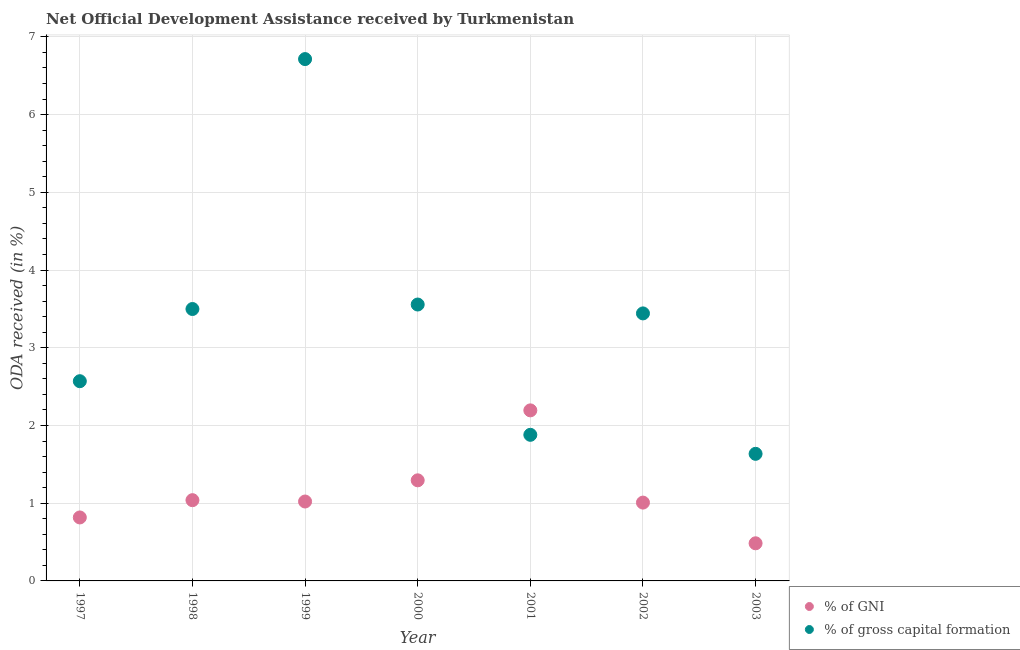How many different coloured dotlines are there?
Ensure brevity in your answer.  2. Is the number of dotlines equal to the number of legend labels?
Provide a succinct answer. Yes. What is the oda received as percentage of gni in 1999?
Your answer should be very brief. 1.02. Across all years, what is the maximum oda received as percentage of gni?
Give a very brief answer. 2.19. Across all years, what is the minimum oda received as percentage of gni?
Your response must be concise. 0.48. What is the total oda received as percentage of gross capital formation in the graph?
Offer a terse response. 23.29. What is the difference between the oda received as percentage of gross capital formation in 1997 and that in 1998?
Your response must be concise. -0.93. What is the difference between the oda received as percentage of gross capital formation in 2003 and the oda received as percentage of gni in 2000?
Provide a succinct answer. 0.34. What is the average oda received as percentage of gni per year?
Offer a terse response. 1.12. In the year 1997, what is the difference between the oda received as percentage of gni and oda received as percentage of gross capital formation?
Your answer should be very brief. -1.75. What is the ratio of the oda received as percentage of gni in 1997 to that in 2003?
Your response must be concise. 1.69. Is the difference between the oda received as percentage of gross capital formation in 1997 and 1999 greater than the difference between the oda received as percentage of gni in 1997 and 1999?
Ensure brevity in your answer.  No. What is the difference between the highest and the second highest oda received as percentage of gni?
Give a very brief answer. 0.9. What is the difference between the highest and the lowest oda received as percentage of gross capital formation?
Provide a short and direct response. 5.08. In how many years, is the oda received as percentage of gni greater than the average oda received as percentage of gni taken over all years?
Ensure brevity in your answer.  2. Is the oda received as percentage of gross capital formation strictly greater than the oda received as percentage of gni over the years?
Your answer should be compact. No. How many dotlines are there?
Offer a very short reply. 2. How many years are there in the graph?
Provide a succinct answer. 7. What is the difference between two consecutive major ticks on the Y-axis?
Your answer should be very brief. 1. Where does the legend appear in the graph?
Provide a short and direct response. Bottom right. How many legend labels are there?
Ensure brevity in your answer.  2. What is the title of the graph?
Your answer should be very brief. Net Official Development Assistance received by Turkmenistan. Does "Primary" appear as one of the legend labels in the graph?
Keep it short and to the point. No. What is the label or title of the X-axis?
Provide a succinct answer. Year. What is the label or title of the Y-axis?
Your answer should be very brief. ODA received (in %). What is the ODA received (in %) of % of GNI in 1997?
Your answer should be compact. 0.82. What is the ODA received (in %) of % of gross capital formation in 1997?
Your response must be concise. 2.57. What is the ODA received (in %) of % of GNI in 1998?
Your answer should be compact. 1.04. What is the ODA received (in %) in % of gross capital formation in 1998?
Give a very brief answer. 3.5. What is the ODA received (in %) of % of GNI in 1999?
Your answer should be compact. 1.02. What is the ODA received (in %) of % of gross capital formation in 1999?
Make the answer very short. 6.71. What is the ODA received (in %) of % of GNI in 2000?
Ensure brevity in your answer.  1.29. What is the ODA received (in %) of % of gross capital formation in 2000?
Your answer should be very brief. 3.56. What is the ODA received (in %) in % of GNI in 2001?
Ensure brevity in your answer.  2.19. What is the ODA received (in %) of % of gross capital formation in 2001?
Your response must be concise. 1.88. What is the ODA received (in %) in % of GNI in 2002?
Your answer should be compact. 1.01. What is the ODA received (in %) in % of gross capital formation in 2002?
Ensure brevity in your answer.  3.44. What is the ODA received (in %) in % of GNI in 2003?
Give a very brief answer. 0.48. What is the ODA received (in %) in % of gross capital formation in 2003?
Ensure brevity in your answer.  1.64. Across all years, what is the maximum ODA received (in %) of % of GNI?
Provide a succinct answer. 2.19. Across all years, what is the maximum ODA received (in %) of % of gross capital formation?
Provide a succinct answer. 6.71. Across all years, what is the minimum ODA received (in %) of % of GNI?
Offer a terse response. 0.48. Across all years, what is the minimum ODA received (in %) of % of gross capital formation?
Provide a short and direct response. 1.64. What is the total ODA received (in %) of % of GNI in the graph?
Ensure brevity in your answer.  7.86. What is the total ODA received (in %) in % of gross capital formation in the graph?
Your answer should be very brief. 23.29. What is the difference between the ODA received (in %) in % of GNI in 1997 and that in 1998?
Provide a short and direct response. -0.22. What is the difference between the ODA received (in %) in % of gross capital formation in 1997 and that in 1998?
Your answer should be very brief. -0.93. What is the difference between the ODA received (in %) of % of GNI in 1997 and that in 1999?
Offer a very short reply. -0.21. What is the difference between the ODA received (in %) in % of gross capital formation in 1997 and that in 1999?
Provide a short and direct response. -4.14. What is the difference between the ODA received (in %) in % of GNI in 1997 and that in 2000?
Keep it short and to the point. -0.48. What is the difference between the ODA received (in %) in % of gross capital formation in 1997 and that in 2000?
Your answer should be compact. -0.99. What is the difference between the ODA received (in %) of % of GNI in 1997 and that in 2001?
Make the answer very short. -1.38. What is the difference between the ODA received (in %) of % of gross capital formation in 1997 and that in 2001?
Offer a very short reply. 0.69. What is the difference between the ODA received (in %) in % of GNI in 1997 and that in 2002?
Keep it short and to the point. -0.19. What is the difference between the ODA received (in %) of % of gross capital formation in 1997 and that in 2002?
Your response must be concise. -0.87. What is the difference between the ODA received (in %) in % of GNI in 1997 and that in 2003?
Ensure brevity in your answer.  0.33. What is the difference between the ODA received (in %) of % of gross capital formation in 1997 and that in 2003?
Keep it short and to the point. 0.93. What is the difference between the ODA received (in %) of % of GNI in 1998 and that in 1999?
Your answer should be compact. 0.02. What is the difference between the ODA received (in %) of % of gross capital formation in 1998 and that in 1999?
Provide a succinct answer. -3.22. What is the difference between the ODA received (in %) of % of GNI in 1998 and that in 2000?
Make the answer very short. -0.26. What is the difference between the ODA received (in %) of % of gross capital formation in 1998 and that in 2000?
Provide a short and direct response. -0.06. What is the difference between the ODA received (in %) in % of GNI in 1998 and that in 2001?
Keep it short and to the point. -1.16. What is the difference between the ODA received (in %) of % of gross capital formation in 1998 and that in 2001?
Give a very brief answer. 1.62. What is the difference between the ODA received (in %) of % of GNI in 1998 and that in 2002?
Your answer should be compact. 0.03. What is the difference between the ODA received (in %) of % of gross capital formation in 1998 and that in 2002?
Keep it short and to the point. 0.06. What is the difference between the ODA received (in %) in % of GNI in 1998 and that in 2003?
Provide a succinct answer. 0.55. What is the difference between the ODA received (in %) in % of gross capital formation in 1998 and that in 2003?
Give a very brief answer. 1.86. What is the difference between the ODA received (in %) of % of GNI in 1999 and that in 2000?
Give a very brief answer. -0.27. What is the difference between the ODA received (in %) in % of gross capital formation in 1999 and that in 2000?
Offer a terse response. 3.16. What is the difference between the ODA received (in %) in % of GNI in 1999 and that in 2001?
Provide a succinct answer. -1.17. What is the difference between the ODA received (in %) of % of gross capital formation in 1999 and that in 2001?
Your answer should be compact. 4.83. What is the difference between the ODA received (in %) of % of GNI in 1999 and that in 2002?
Keep it short and to the point. 0.01. What is the difference between the ODA received (in %) in % of gross capital formation in 1999 and that in 2002?
Give a very brief answer. 3.27. What is the difference between the ODA received (in %) in % of GNI in 1999 and that in 2003?
Offer a very short reply. 0.54. What is the difference between the ODA received (in %) of % of gross capital formation in 1999 and that in 2003?
Offer a very short reply. 5.08. What is the difference between the ODA received (in %) of % of gross capital formation in 2000 and that in 2001?
Your answer should be compact. 1.68. What is the difference between the ODA received (in %) of % of GNI in 2000 and that in 2002?
Offer a terse response. 0.29. What is the difference between the ODA received (in %) in % of gross capital formation in 2000 and that in 2002?
Make the answer very short. 0.11. What is the difference between the ODA received (in %) of % of GNI in 2000 and that in 2003?
Keep it short and to the point. 0.81. What is the difference between the ODA received (in %) of % of gross capital formation in 2000 and that in 2003?
Your response must be concise. 1.92. What is the difference between the ODA received (in %) in % of GNI in 2001 and that in 2002?
Your response must be concise. 1.19. What is the difference between the ODA received (in %) in % of gross capital formation in 2001 and that in 2002?
Your answer should be very brief. -1.56. What is the difference between the ODA received (in %) in % of GNI in 2001 and that in 2003?
Provide a short and direct response. 1.71. What is the difference between the ODA received (in %) of % of gross capital formation in 2001 and that in 2003?
Ensure brevity in your answer.  0.24. What is the difference between the ODA received (in %) in % of GNI in 2002 and that in 2003?
Give a very brief answer. 0.52. What is the difference between the ODA received (in %) of % of gross capital formation in 2002 and that in 2003?
Your answer should be compact. 1.81. What is the difference between the ODA received (in %) in % of GNI in 1997 and the ODA received (in %) in % of gross capital formation in 1998?
Offer a very short reply. -2.68. What is the difference between the ODA received (in %) in % of GNI in 1997 and the ODA received (in %) in % of gross capital formation in 1999?
Provide a succinct answer. -5.9. What is the difference between the ODA received (in %) of % of GNI in 1997 and the ODA received (in %) of % of gross capital formation in 2000?
Your response must be concise. -2.74. What is the difference between the ODA received (in %) in % of GNI in 1997 and the ODA received (in %) in % of gross capital formation in 2001?
Your response must be concise. -1.06. What is the difference between the ODA received (in %) of % of GNI in 1997 and the ODA received (in %) of % of gross capital formation in 2002?
Offer a terse response. -2.63. What is the difference between the ODA received (in %) of % of GNI in 1997 and the ODA received (in %) of % of gross capital formation in 2003?
Ensure brevity in your answer.  -0.82. What is the difference between the ODA received (in %) of % of GNI in 1998 and the ODA received (in %) of % of gross capital formation in 1999?
Provide a short and direct response. -5.67. What is the difference between the ODA received (in %) in % of GNI in 1998 and the ODA received (in %) in % of gross capital formation in 2000?
Give a very brief answer. -2.52. What is the difference between the ODA received (in %) of % of GNI in 1998 and the ODA received (in %) of % of gross capital formation in 2001?
Make the answer very short. -0.84. What is the difference between the ODA received (in %) of % of GNI in 1998 and the ODA received (in %) of % of gross capital formation in 2002?
Your response must be concise. -2.4. What is the difference between the ODA received (in %) in % of GNI in 1998 and the ODA received (in %) in % of gross capital formation in 2003?
Offer a terse response. -0.6. What is the difference between the ODA received (in %) in % of GNI in 1999 and the ODA received (in %) in % of gross capital formation in 2000?
Your answer should be compact. -2.53. What is the difference between the ODA received (in %) of % of GNI in 1999 and the ODA received (in %) of % of gross capital formation in 2001?
Your answer should be very brief. -0.86. What is the difference between the ODA received (in %) in % of GNI in 1999 and the ODA received (in %) in % of gross capital formation in 2002?
Ensure brevity in your answer.  -2.42. What is the difference between the ODA received (in %) in % of GNI in 1999 and the ODA received (in %) in % of gross capital formation in 2003?
Your answer should be very brief. -0.61. What is the difference between the ODA received (in %) of % of GNI in 2000 and the ODA received (in %) of % of gross capital formation in 2001?
Provide a short and direct response. -0.59. What is the difference between the ODA received (in %) of % of GNI in 2000 and the ODA received (in %) of % of gross capital formation in 2002?
Keep it short and to the point. -2.15. What is the difference between the ODA received (in %) of % of GNI in 2000 and the ODA received (in %) of % of gross capital formation in 2003?
Offer a very short reply. -0.34. What is the difference between the ODA received (in %) in % of GNI in 2001 and the ODA received (in %) in % of gross capital formation in 2002?
Make the answer very short. -1.25. What is the difference between the ODA received (in %) of % of GNI in 2001 and the ODA received (in %) of % of gross capital formation in 2003?
Ensure brevity in your answer.  0.56. What is the difference between the ODA received (in %) of % of GNI in 2002 and the ODA received (in %) of % of gross capital formation in 2003?
Keep it short and to the point. -0.63. What is the average ODA received (in %) in % of GNI per year?
Make the answer very short. 1.12. What is the average ODA received (in %) in % of gross capital formation per year?
Provide a succinct answer. 3.33. In the year 1997, what is the difference between the ODA received (in %) of % of GNI and ODA received (in %) of % of gross capital formation?
Offer a very short reply. -1.75. In the year 1998, what is the difference between the ODA received (in %) in % of GNI and ODA received (in %) in % of gross capital formation?
Offer a terse response. -2.46. In the year 1999, what is the difference between the ODA received (in %) in % of GNI and ODA received (in %) in % of gross capital formation?
Provide a short and direct response. -5.69. In the year 2000, what is the difference between the ODA received (in %) in % of GNI and ODA received (in %) in % of gross capital formation?
Offer a very short reply. -2.26. In the year 2001, what is the difference between the ODA received (in %) in % of GNI and ODA received (in %) in % of gross capital formation?
Keep it short and to the point. 0.31. In the year 2002, what is the difference between the ODA received (in %) of % of GNI and ODA received (in %) of % of gross capital formation?
Your answer should be compact. -2.43. In the year 2003, what is the difference between the ODA received (in %) of % of GNI and ODA received (in %) of % of gross capital formation?
Ensure brevity in your answer.  -1.15. What is the ratio of the ODA received (in %) of % of GNI in 1997 to that in 1998?
Make the answer very short. 0.79. What is the ratio of the ODA received (in %) in % of gross capital formation in 1997 to that in 1998?
Provide a short and direct response. 0.73. What is the ratio of the ODA received (in %) of % of GNI in 1997 to that in 1999?
Ensure brevity in your answer.  0.8. What is the ratio of the ODA received (in %) in % of gross capital formation in 1997 to that in 1999?
Provide a short and direct response. 0.38. What is the ratio of the ODA received (in %) of % of GNI in 1997 to that in 2000?
Make the answer very short. 0.63. What is the ratio of the ODA received (in %) in % of gross capital formation in 1997 to that in 2000?
Offer a terse response. 0.72. What is the ratio of the ODA received (in %) in % of GNI in 1997 to that in 2001?
Offer a very short reply. 0.37. What is the ratio of the ODA received (in %) of % of gross capital formation in 1997 to that in 2001?
Provide a succinct answer. 1.37. What is the ratio of the ODA received (in %) of % of GNI in 1997 to that in 2002?
Your response must be concise. 0.81. What is the ratio of the ODA received (in %) of % of gross capital formation in 1997 to that in 2002?
Provide a short and direct response. 0.75. What is the ratio of the ODA received (in %) of % of GNI in 1997 to that in 2003?
Offer a terse response. 1.69. What is the ratio of the ODA received (in %) in % of gross capital formation in 1997 to that in 2003?
Your answer should be compact. 1.57. What is the ratio of the ODA received (in %) in % of GNI in 1998 to that in 1999?
Provide a succinct answer. 1.02. What is the ratio of the ODA received (in %) in % of gross capital formation in 1998 to that in 1999?
Offer a terse response. 0.52. What is the ratio of the ODA received (in %) in % of GNI in 1998 to that in 2000?
Provide a short and direct response. 0.8. What is the ratio of the ODA received (in %) of % of gross capital formation in 1998 to that in 2000?
Offer a terse response. 0.98. What is the ratio of the ODA received (in %) of % of GNI in 1998 to that in 2001?
Your response must be concise. 0.47. What is the ratio of the ODA received (in %) in % of gross capital formation in 1998 to that in 2001?
Make the answer very short. 1.86. What is the ratio of the ODA received (in %) in % of GNI in 1998 to that in 2002?
Provide a succinct answer. 1.03. What is the ratio of the ODA received (in %) of % of gross capital formation in 1998 to that in 2002?
Give a very brief answer. 1.02. What is the ratio of the ODA received (in %) of % of GNI in 1998 to that in 2003?
Give a very brief answer. 2.15. What is the ratio of the ODA received (in %) in % of gross capital formation in 1998 to that in 2003?
Your answer should be compact. 2.14. What is the ratio of the ODA received (in %) of % of GNI in 1999 to that in 2000?
Your answer should be compact. 0.79. What is the ratio of the ODA received (in %) of % of gross capital formation in 1999 to that in 2000?
Offer a very short reply. 1.89. What is the ratio of the ODA received (in %) of % of GNI in 1999 to that in 2001?
Provide a short and direct response. 0.47. What is the ratio of the ODA received (in %) in % of gross capital formation in 1999 to that in 2001?
Make the answer very short. 3.57. What is the ratio of the ODA received (in %) in % of GNI in 1999 to that in 2002?
Your answer should be compact. 1.01. What is the ratio of the ODA received (in %) of % of gross capital formation in 1999 to that in 2002?
Offer a terse response. 1.95. What is the ratio of the ODA received (in %) in % of GNI in 1999 to that in 2003?
Offer a very short reply. 2.11. What is the ratio of the ODA received (in %) of % of gross capital formation in 1999 to that in 2003?
Your answer should be compact. 4.11. What is the ratio of the ODA received (in %) of % of GNI in 2000 to that in 2001?
Provide a succinct answer. 0.59. What is the ratio of the ODA received (in %) of % of gross capital formation in 2000 to that in 2001?
Make the answer very short. 1.89. What is the ratio of the ODA received (in %) in % of GNI in 2000 to that in 2002?
Your answer should be very brief. 1.28. What is the ratio of the ODA received (in %) of % of gross capital formation in 2000 to that in 2002?
Your response must be concise. 1.03. What is the ratio of the ODA received (in %) in % of GNI in 2000 to that in 2003?
Your answer should be compact. 2.67. What is the ratio of the ODA received (in %) of % of gross capital formation in 2000 to that in 2003?
Ensure brevity in your answer.  2.17. What is the ratio of the ODA received (in %) in % of GNI in 2001 to that in 2002?
Your answer should be compact. 2.18. What is the ratio of the ODA received (in %) of % of gross capital formation in 2001 to that in 2002?
Your answer should be very brief. 0.55. What is the ratio of the ODA received (in %) of % of GNI in 2001 to that in 2003?
Provide a succinct answer. 4.53. What is the ratio of the ODA received (in %) of % of gross capital formation in 2001 to that in 2003?
Provide a short and direct response. 1.15. What is the ratio of the ODA received (in %) of % of GNI in 2002 to that in 2003?
Provide a succinct answer. 2.08. What is the ratio of the ODA received (in %) of % of gross capital formation in 2002 to that in 2003?
Your response must be concise. 2.1. What is the difference between the highest and the second highest ODA received (in %) in % of GNI?
Your answer should be compact. 0.9. What is the difference between the highest and the second highest ODA received (in %) in % of gross capital formation?
Offer a very short reply. 3.16. What is the difference between the highest and the lowest ODA received (in %) in % of GNI?
Ensure brevity in your answer.  1.71. What is the difference between the highest and the lowest ODA received (in %) in % of gross capital formation?
Make the answer very short. 5.08. 